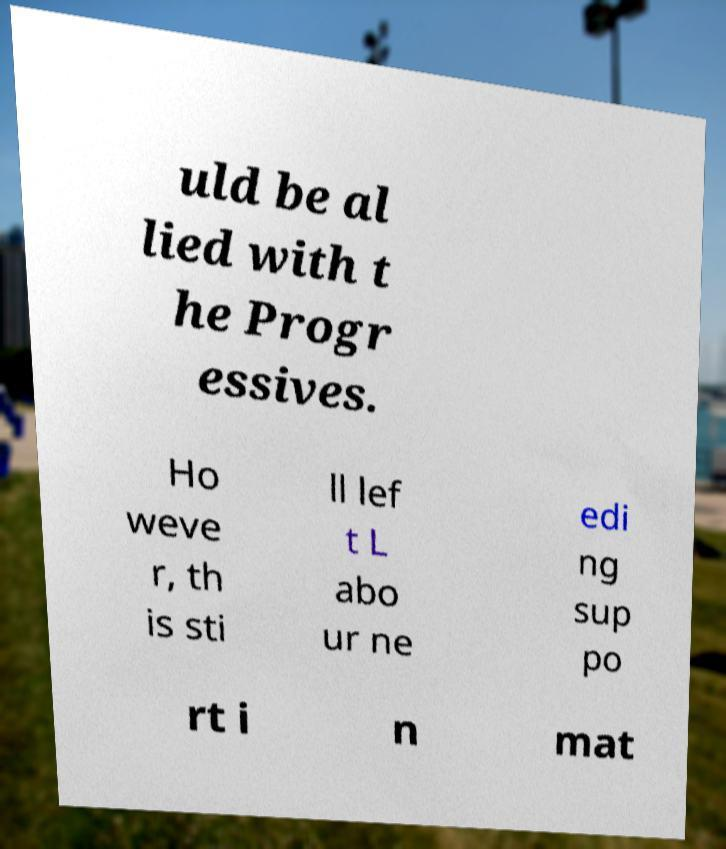Can you read and provide the text displayed in the image?This photo seems to have some interesting text. Can you extract and type it out for me? uld be al lied with t he Progr essives. Ho weve r, th is sti ll lef t L abo ur ne edi ng sup po rt i n mat 